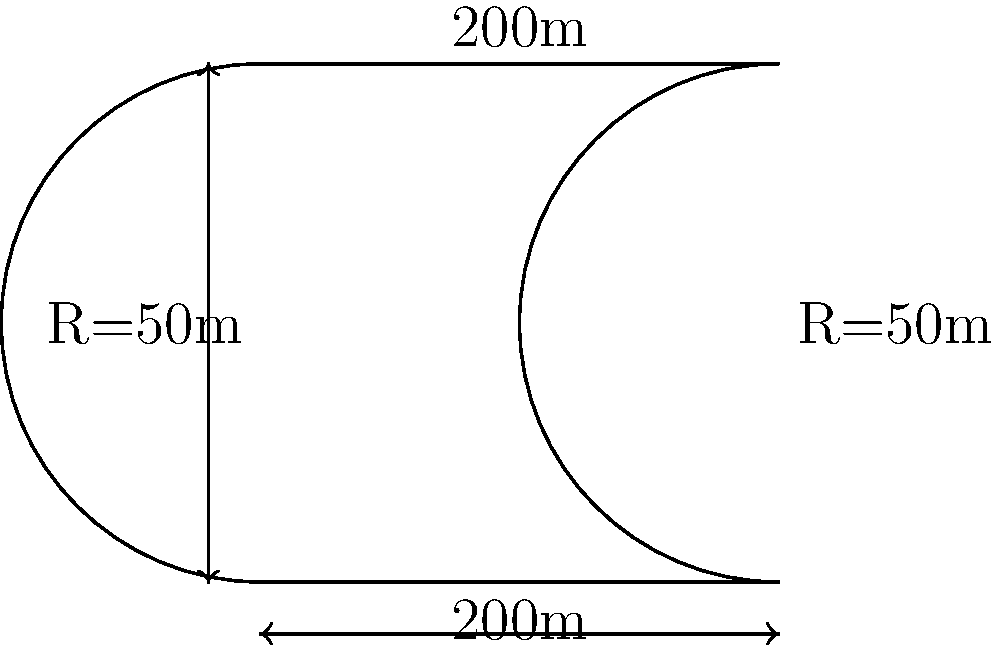As a motorsport engineer, you're tasked with calculating the total area of a new racetrack. The track has two straight sections, each 200 meters long, connected by two semicircular turns with a radius of 50 meters each, as shown in the diagram. What is the total area enclosed by this racetrack in square meters? Let's break this down step-by-step:

1) The racetrack consists of two rectangles (the straight sections) and two semicircles (the turns).

2) Area of rectangles:
   - Length = 200m, Width = 100m (distance between centers of semicircles)
   - Area of rectangles = $200m \times 100m = 20,000m^2$

3) Area of semicircles:
   - Radius = 50m
   - Area of a full circle = $\pi r^2 = \pi \times 50^2 = 2,500\pi m^2$
   - Area of semicircle = $\frac{1}{2} \times 2,500\pi m^2 = 1,250\pi m^2$
   - Area of two semicircles = $2 \times 1,250\pi m^2 = 2,500\pi m^2$

4) Total area:
   $\text{Total Area} = \text{Area of rectangles} + \text{Area of semicircles}$
   $= 20,000m^2 + 2,500\pi m^2$
   $= 20,000 + 2,500\pi m^2$
   $\approx 27,853.98 m^2$

Therefore, the total area enclosed by the racetrack is approximately 27,853.98 square meters.
Answer: $20,000 + 2,500\pi$ square meters 